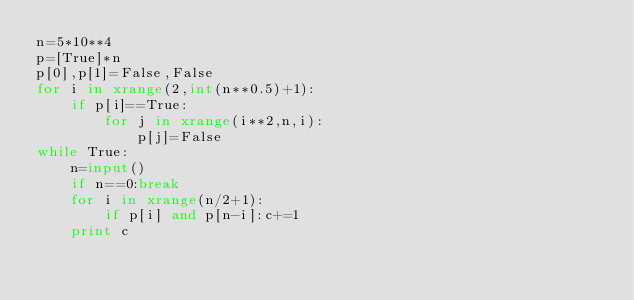<code> <loc_0><loc_0><loc_500><loc_500><_Python_>n=5*10**4
p=[True]*n
p[0],p[1]=False,False
for i in xrange(2,int(n**0.5)+1):
    if p[i]==True:
        for j in xrange(i**2,n,i):
            p[j]=False
while True:
    n=input()
    if n==0:break
    for i in xrange(n/2+1):
        if p[i] and p[n-i]:c+=1
    print c</code> 